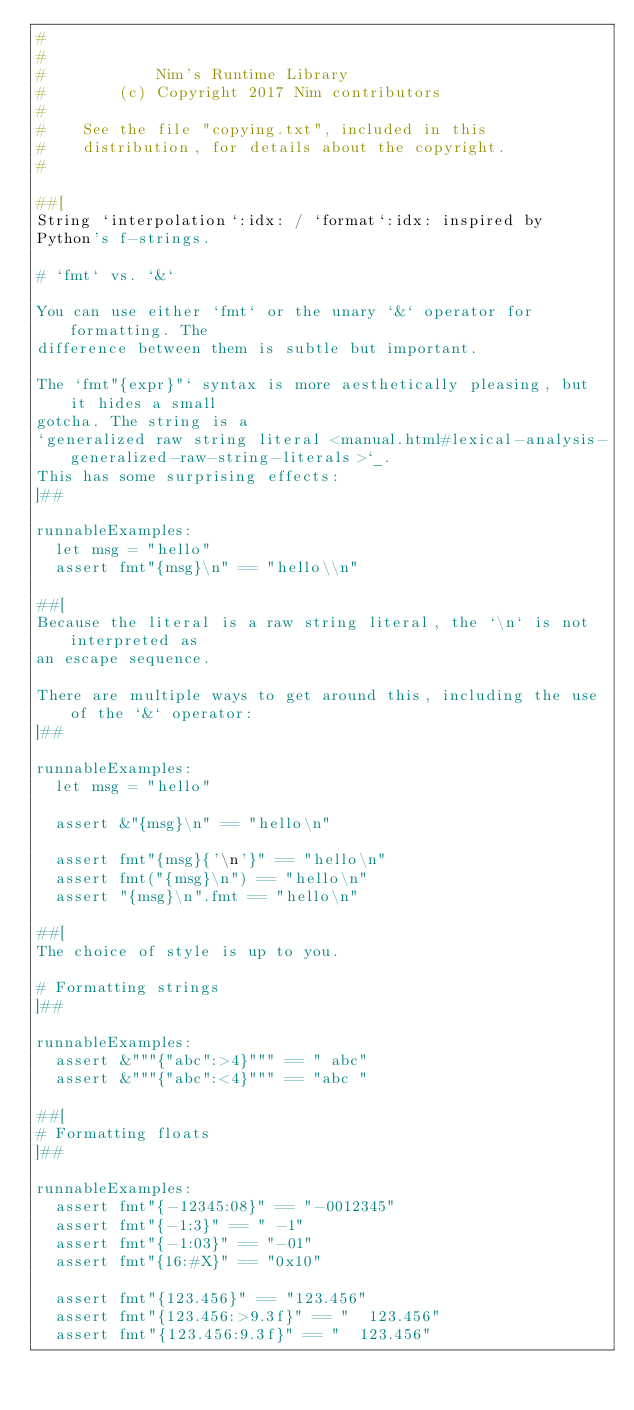<code> <loc_0><loc_0><loc_500><loc_500><_Nim_>#
#
#            Nim's Runtime Library
#        (c) Copyright 2017 Nim contributors
#
#    See the file "copying.txt", included in this
#    distribution, for details about the copyright.
#

##[
String `interpolation`:idx: / `format`:idx: inspired by
Python's f-strings.

# `fmt` vs. `&`

You can use either `fmt` or the unary `&` operator for formatting. The
difference between them is subtle but important.

The `fmt"{expr}"` syntax is more aesthetically pleasing, but it hides a small
gotcha. The string is a
`generalized raw string literal <manual.html#lexical-analysis-generalized-raw-string-literals>`_.
This has some surprising effects:
]##

runnableExamples:
  let msg = "hello"
  assert fmt"{msg}\n" == "hello\\n"

##[
Because the literal is a raw string literal, the `\n` is not interpreted as
an escape sequence.

There are multiple ways to get around this, including the use of the `&` operator:
]##

runnableExamples:
  let msg = "hello"

  assert &"{msg}\n" == "hello\n"

  assert fmt"{msg}{'\n'}" == "hello\n"
  assert fmt("{msg}\n") == "hello\n"
  assert "{msg}\n".fmt == "hello\n"

##[
The choice of style is up to you.

# Formatting strings
]##

runnableExamples:
  assert &"""{"abc":>4}""" == " abc"
  assert &"""{"abc":<4}""" == "abc "

##[
# Formatting floats
]##

runnableExamples:
  assert fmt"{-12345:08}" == "-0012345"
  assert fmt"{-1:3}" == " -1"
  assert fmt"{-1:03}" == "-01"
  assert fmt"{16:#X}" == "0x10"

  assert fmt"{123.456}" == "123.456"
  assert fmt"{123.456:>9.3f}" == "  123.456"
  assert fmt"{123.456:9.3f}" == "  123.456"</code> 